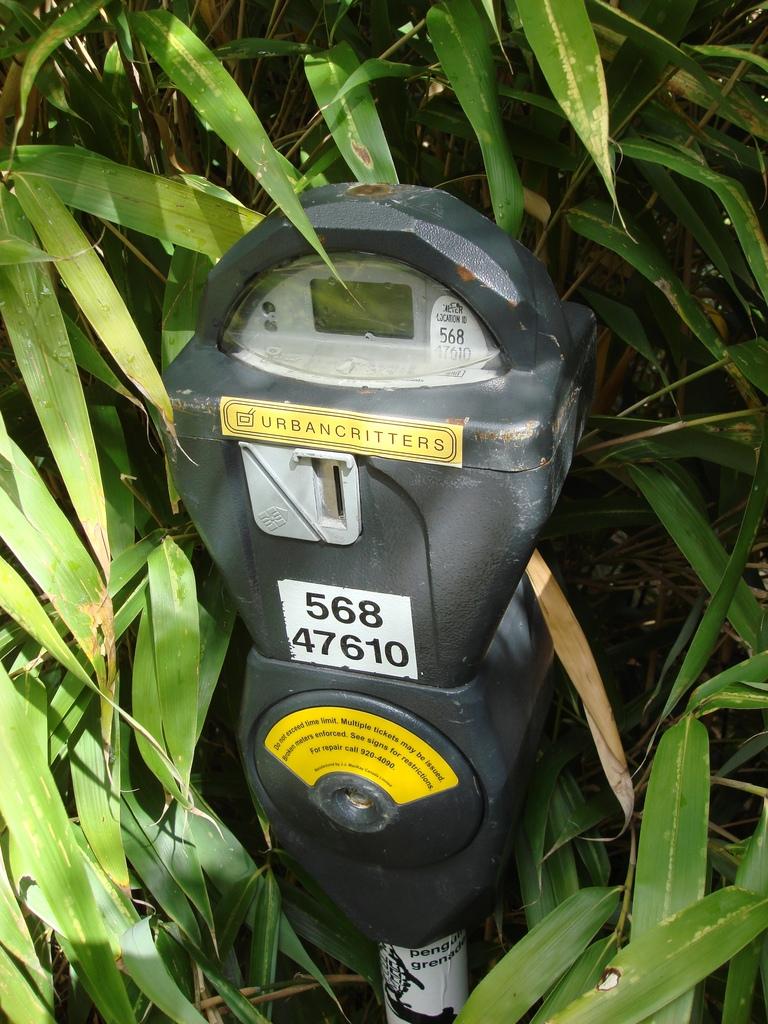What does the sticker above the coin slot say?
Offer a terse response. Urbancritters. What 8 digit number is displayed on this meter?
Offer a terse response. 56847610. 